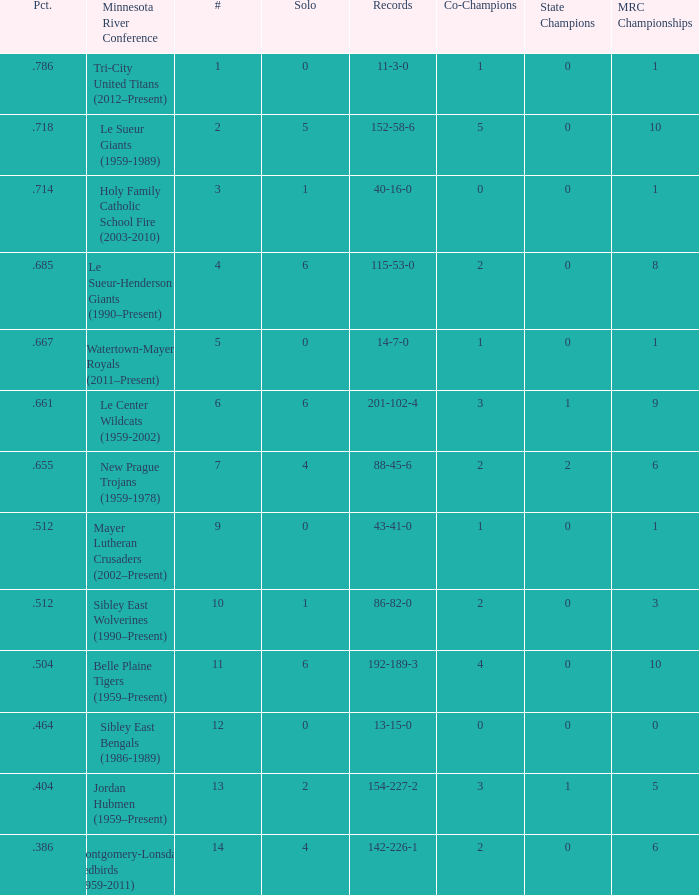Write the full table. {'header': ['Pct.', 'Minnesota River Conference', '#', 'Solo', 'Records', 'Co-Champions', 'State Champions', 'MRC Championships'], 'rows': [['.786', 'Tri-City United Titans (2012–Present)', '1', '0', '11-3-0', '1', '0', '1'], ['.718', 'Le Sueur Giants (1959-1989)', '2', '5', '152-58-6', '5', '0', '10'], ['.714', 'Holy Family Catholic School Fire (2003-2010)', '3', '1', '40-16-0', '0', '0', '1'], ['.685', 'Le Sueur-Henderson Giants (1990–Present)', '4', '6', '115-53-0', '2', '0', '8'], ['.667', 'Watertown-Mayer Royals (2011–Present)', '5', '0', '14-7-0', '1', '0', '1'], ['.661', 'Le Center Wildcats (1959-2002)', '6', '6', '201-102-4', '3', '1', '9'], ['.655', 'New Prague Trojans (1959-1978)', '7', '4', '88-45-6', '2', '2', '6'], ['.512', 'Mayer Lutheran Crusaders (2002–Present)', '9', '0', '43-41-0', '1', '0', '1'], ['.512', 'Sibley East Wolverines (1990–Present)', '10', '1', '86-82-0', '2', '0', '3'], ['.504', 'Belle Plaine Tigers (1959–Present)', '11', '6', '192-189-3', '4', '0', '10'], ['.464', 'Sibley East Bengals (1986-1989)', '12', '0', '13-15-0', '0', '0', '0'], ['.404', 'Jordan Hubmen (1959–Present)', '13', '2', '154-227-2', '3', '1', '5'], ['.386', 'Montgomery-Lonsdale Redbirds (1959-2011)', '14', '4', '142-226-1', '2', '0', '6']]} How many teams are #2 on the list? 1.0. 